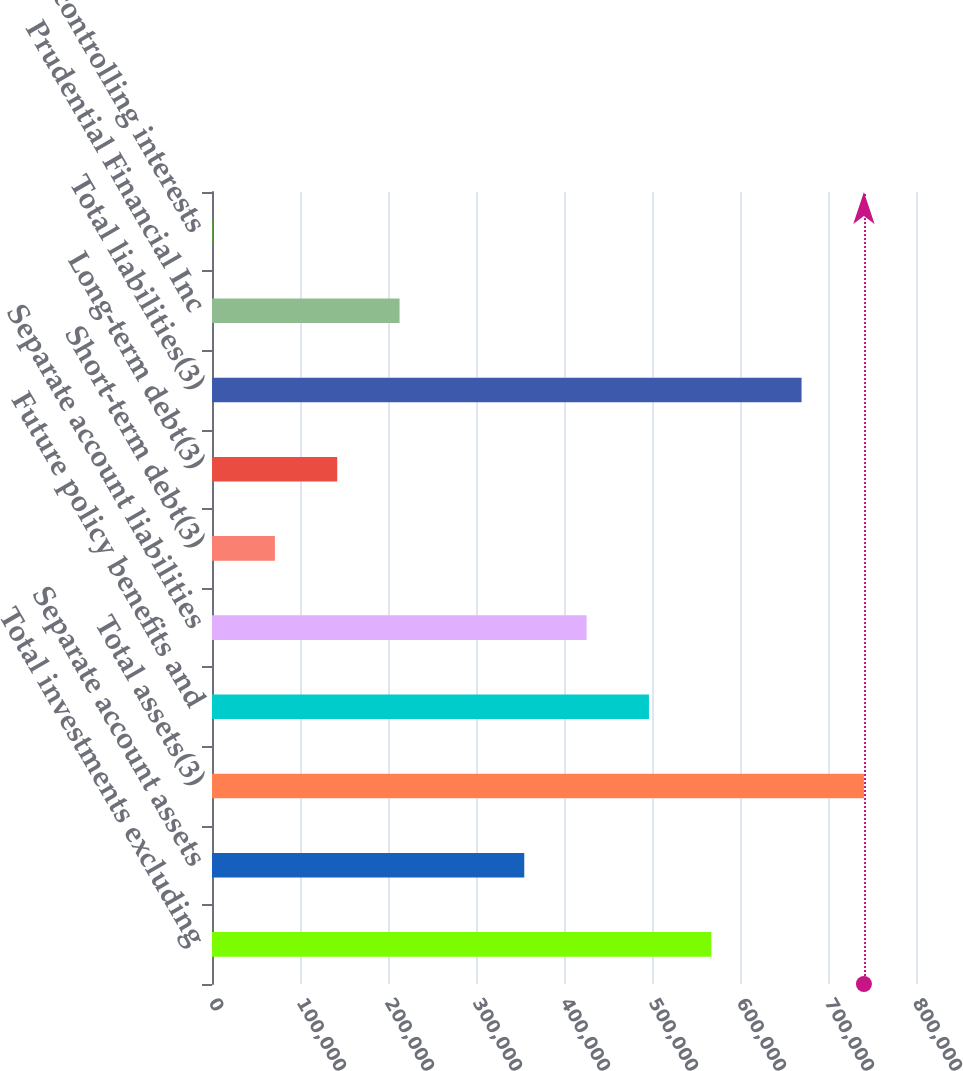<chart> <loc_0><loc_0><loc_500><loc_500><bar_chart><fcel>Total investments excluding<fcel>Separate account assets<fcel>Total assets(3)<fcel>Future policy benefits and<fcel>Separate account liabilities<fcel>Short-term debt(3)<fcel>Long-term debt(3)<fcel>Total liabilities(3)<fcel>Prudential Financial Inc<fcel>Noncontrolling interests<nl><fcel>567389<fcel>354846<fcel>740820<fcel>496542<fcel>425694<fcel>71456.5<fcel>142304<fcel>669972<fcel>213152<fcel>609<nl></chart> 